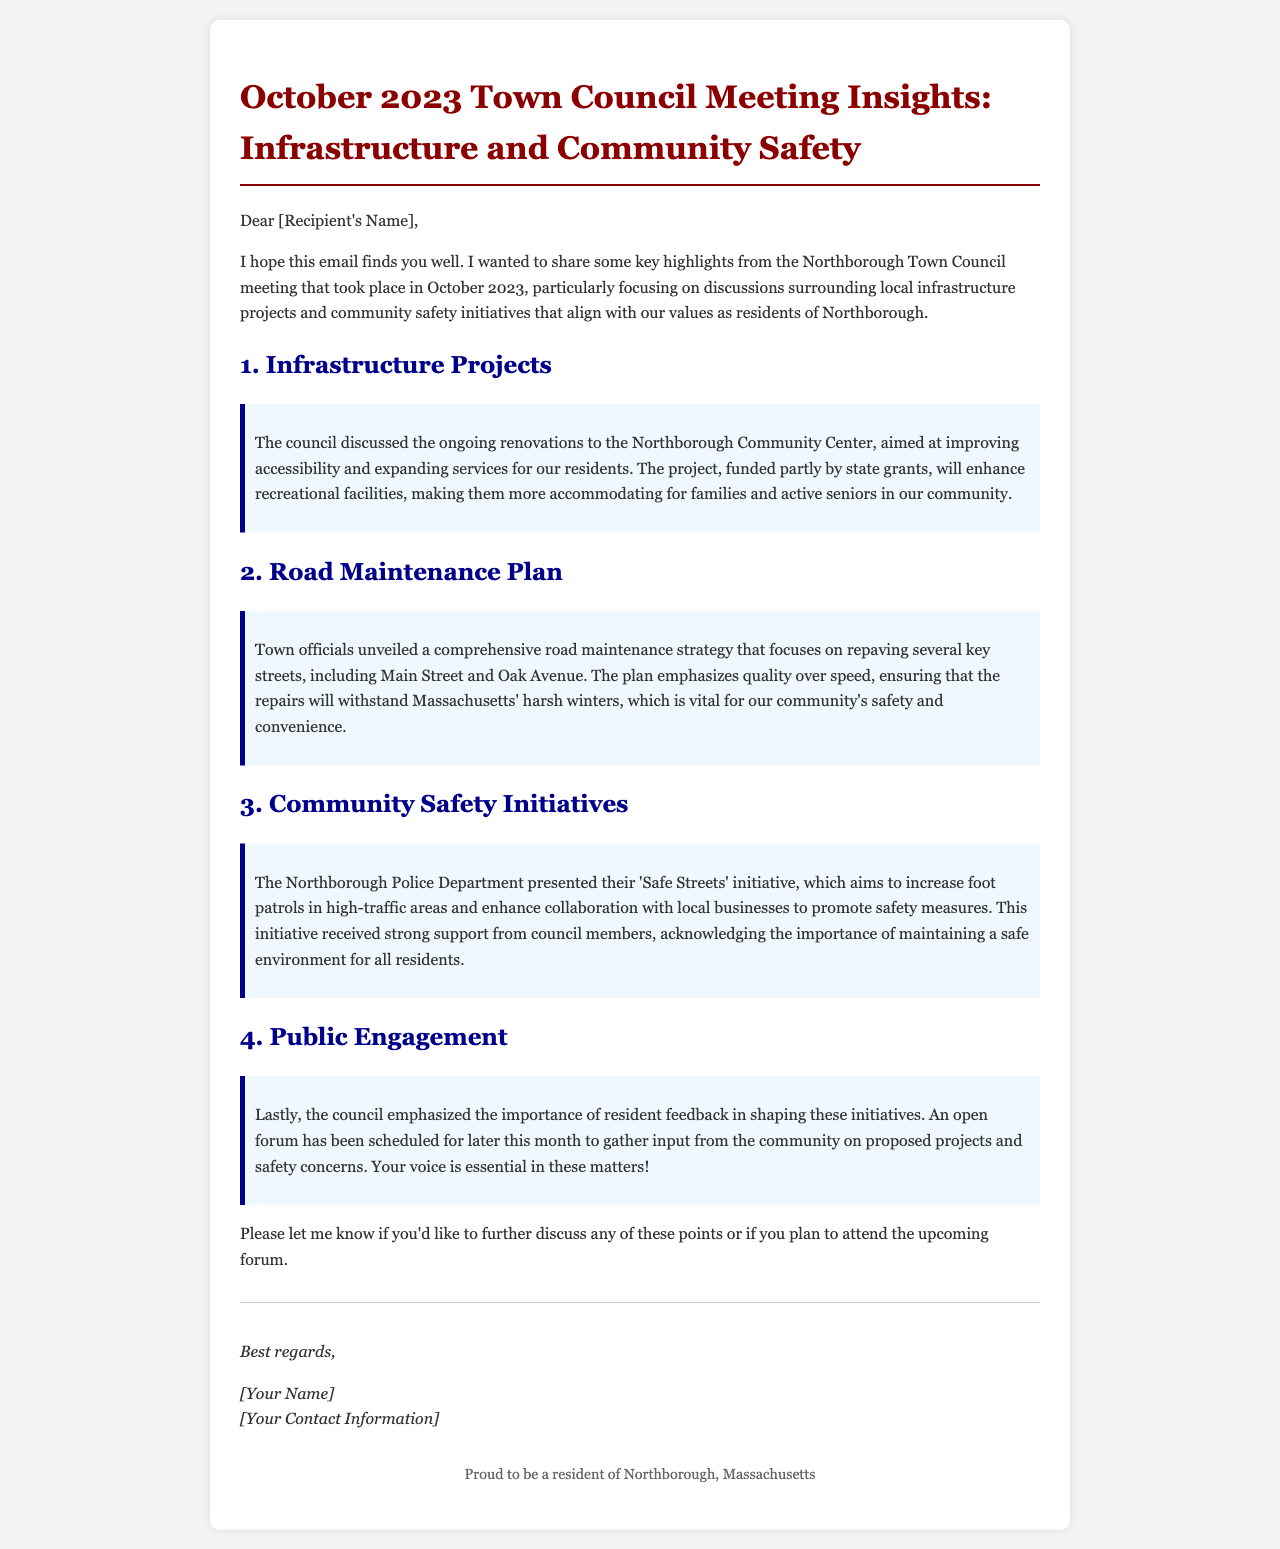What was the focus of the October 2023 Town Council meeting? The main focus of the meeting was on local infrastructure projects and community safety initiatives.
Answer: Infrastructure projects and community safety initiatives What renovation project was discussed for the Northborough Community Center? The council discussed ongoing renovations aimed at improving accessibility and expanding services.
Answer: Improving accessibility and expanding services Which streets are included in the road maintenance plan? The plan includes repaving Main Street and Oak Avenue.
Answer: Main Street and Oak Avenue What is the name of the police initiative presented at the meeting? The police initiative presented was called 'Safe Streets.'
Answer: Safe Streets What was emphasized regarding resident involvement? The council emphasized the importance of resident feedback in shaping initiatives.
Answer: Importance of resident feedback When is the open forum scheduled? The open forum is scheduled for later this month.
Answer: Later this month What type of funding is partly used for the Community Center project? The project is partly funded by state grants.
Answer: State grants What safety measures are promoted in the 'Safe Streets' initiative? The initiative promotes increased foot patrols and collaboration with local businesses.
Answer: Increased foot patrols and collaboration with local businesses 